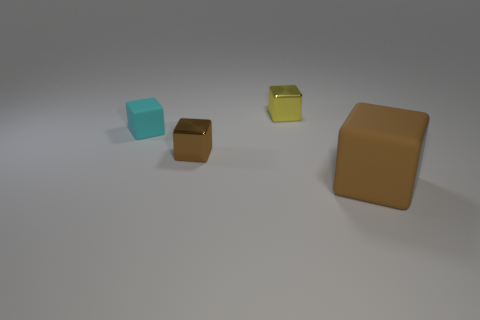What material is the brown object on the right side of the metallic cube that is to the right of the small brown metal cube?
Ensure brevity in your answer.  Rubber. What is the shape of the small yellow object?
Your answer should be very brief. Cube. What material is the tiny cyan thing that is the same shape as the yellow thing?
Provide a short and direct response. Rubber. How many cyan matte objects have the same size as the cyan rubber cube?
Your response must be concise. 0. There is a large brown rubber cube on the right side of the yellow cube; are there any small shiny blocks to the right of it?
Your answer should be compact. No. How many yellow things are large cubes or tiny things?
Provide a short and direct response. 1. The big matte object is what color?
Provide a short and direct response. Brown. There is another object that is the same material as the cyan object; what is its size?
Your response must be concise. Large. How many cyan objects are the same shape as the brown metal object?
Make the answer very short. 1. Are there any other things that are the same size as the yellow metal block?
Provide a succinct answer. Yes. 